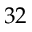<formula> <loc_0><loc_0><loc_500><loc_500>3 2</formula> 